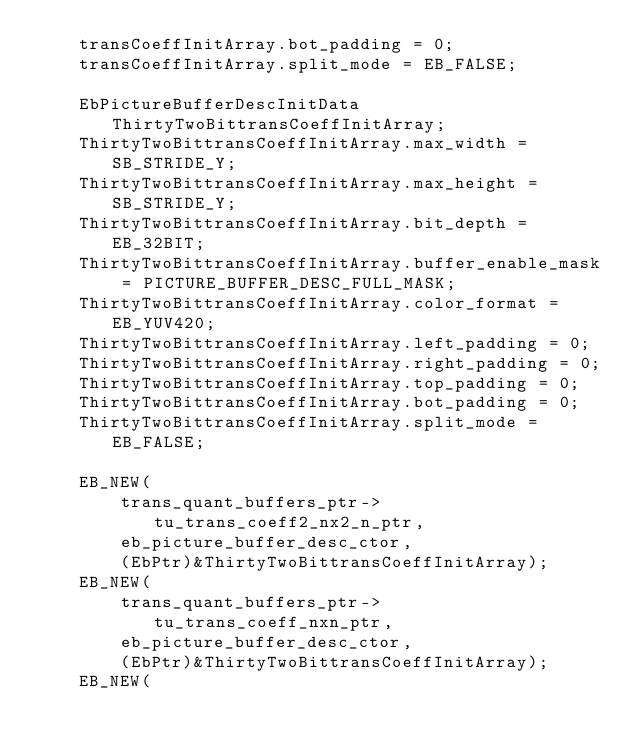Convert code to text. <code><loc_0><loc_0><loc_500><loc_500><_C_>    transCoeffInitArray.bot_padding = 0;
    transCoeffInitArray.split_mode = EB_FALSE;

    EbPictureBufferDescInitData ThirtyTwoBittransCoeffInitArray;
    ThirtyTwoBittransCoeffInitArray.max_width = SB_STRIDE_Y;
    ThirtyTwoBittransCoeffInitArray.max_height = SB_STRIDE_Y;
    ThirtyTwoBittransCoeffInitArray.bit_depth = EB_32BIT;
    ThirtyTwoBittransCoeffInitArray.buffer_enable_mask = PICTURE_BUFFER_DESC_FULL_MASK;
    ThirtyTwoBittransCoeffInitArray.color_format = EB_YUV420;
    ThirtyTwoBittransCoeffInitArray.left_padding = 0;
    ThirtyTwoBittransCoeffInitArray.right_padding = 0;
    ThirtyTwoBittransCoeffInitArray.top_padding = 0;
    ThirtyTwoBittransCoeffInitArray.bot_padding = 0;
    ThirtyTwoBittransCoeffInitArray.split_mode = EB_FALSE;

    EB_NEW(
        trans_quant_buffers_ptr->tu_trans_coeff2_nx2_n_ptr,
        eb_picture_buffer_desc_ctor,
        (EbPtr)&ThirtyTwoBittransCoeffInitArray);
    EB_NEW(
        trans_quant_buffers_ptr->tu_trans_coeff_nxn_ptr,
        eb_picture_buffer_desc_ctor,
        (EbPtr)&ThirtyTwoBittransCoeffInitArray);
    EB_NEW(</code> 